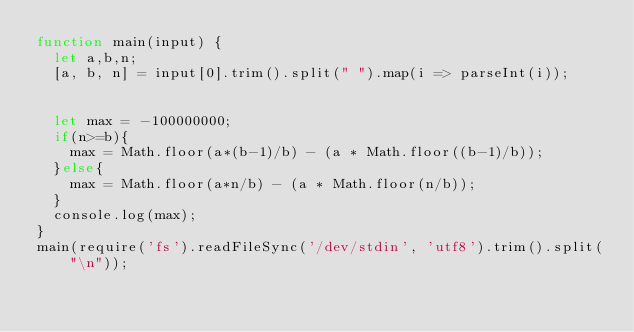Convert code to text. <code><loc_0><loc_0><loc_500><loc_500><_JavaScript_>function main(input) {
  let a,b,n;
  [a, b, n] = input[0].trim().split(" ").map(i => parseInt(i));

  
  let max = -100000000;
  if(n>=b){
    max = Math.floor(a*(b-1)/b) - (a * Math.floor((b-1)/b));
  }else{
    max = Math.floor(a*n/b) - (a * Math.floor(n/b));
  }
  console.log(max);
}
main(require('fs').readFileSync('/dev/stdin', 'utf8').trim().split("\n"));</code> 